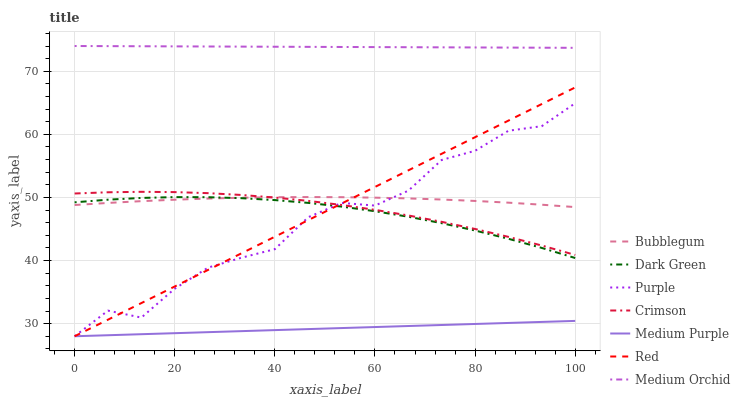Does Medium Purple have the minimum area under the curve?
Answer yes or no. Yes. Does Medium Orchid have the maximum area under the curve?
Answer yes or no. Yes. Does Bubblegum have the minimum area under the curve?
Answer yes or no. No. Does Bubblegum have the maximum area under the curve?
Answer yes or no. No. Is Medium Purple the smoothest?
Answer yes or no. Yes. Is Purple the roughest?
Answer yes or no. Yes. Is Medium Orchid the smoothest?
Answer yes or no. No. Is Medium Orchid the roughest?
Answer yes or no. No. Does Purple have the lowest value?
Answer yes or no. Yes. Does Bubblegum have the lowest value?
Answer yes or no. No. Does Medium Orchid have the highest value?
Answer yes or no. Yes. Does Bubblegum have the highest value?
Answer yes or no. No. Is Dark Green less than Medium Orchid?
Answer yes or no. Yes. Is Crimson greater than Medium Purple?
Answer yes or no. Yes. Does Medium Purple intersect Red?
Answer yes or no. Yes. Is Medium Purple less than Red?
Answer yes or no. No. Is Medium Purple greater than Red?
Answer yes or no. No. Does Dark Green intersect Medium Orchid?
Answer yes or no. No. 